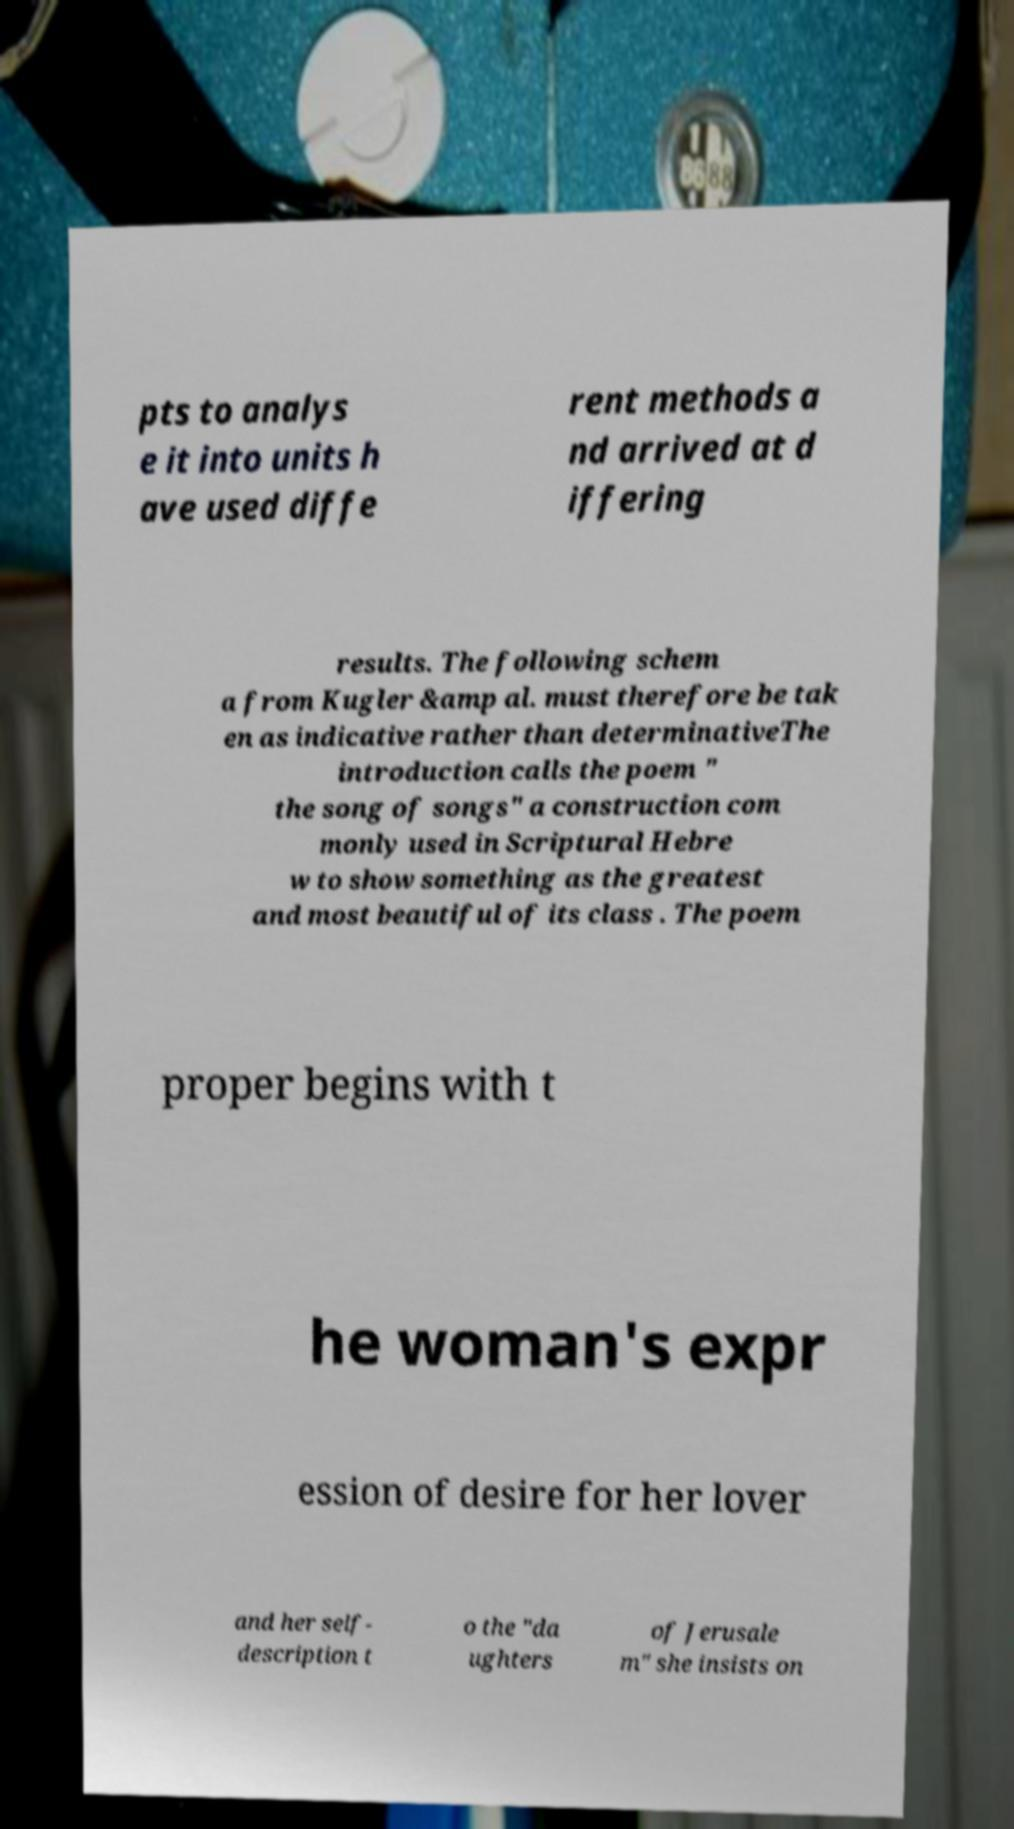Can you accurately transcribe the text from the provided image for me? pts to analys e it into units h ave used diffe rent methods a nd arrived at d iffering results. The following schem a from Kugler &amp al. must therefore be tak en as indicative rather than determinativeThe introduction calls the poem " the song of songs" a construction com monly used in Scriptural Hebre w to show something as the greatest and most beautiful of its class . The poem proper begins with t he woman's expr ession of desire for her lover and her self- description t o the "da ughters of Jerusale m" she insists on 